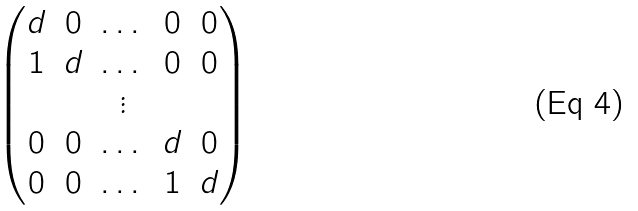<formula> <loc_0><loc_0><loc_500><loc_500>\begin{pmatrix} d & 0 & \dots & 0 & 0 \\ 1 & d & \dots & 0 & 0 \\ & & \vdots \\ 0 & 0 & \dots & d & 0 \\ 0 & 0 & \dots & 1 & d \end{pmatrix}</formula> 